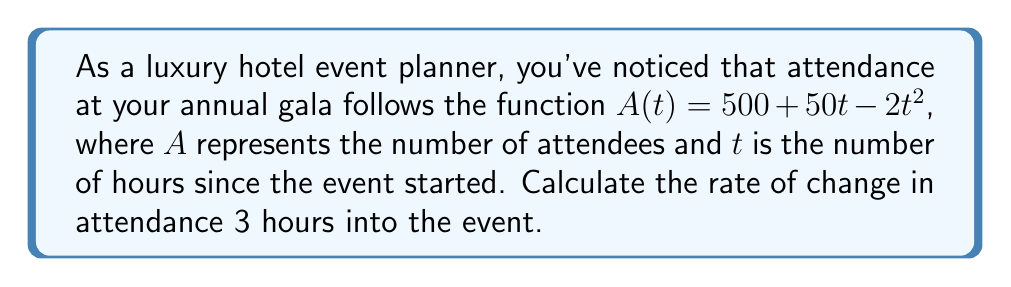Teach me how to tackle this problem. To find the rate of change in attendance at a specific time, we need to calculate the derivative of the attendance function and evaluate it at the given time.

1. The attendance function is: $A(t) = 500 + 50t - 2t^2$

2. To find the rate of change, we need to calculate $\frac{dA}{dt}$:
   $$\frac{dA}{dt} = \frac{d}{dt}(500 + 50t - 2t^2)$$

3. Using the power rule and constant rule of derivatives:
   $$\frac{dA}{dt} = 0 + 50 - 4t$$

4. Simplify:
   $$\frac{dA}{dt} = 50 - 4t$$

5. Now, we need to evaluate this at $t = 3$ hours:
   $$\frac{dA}{dt}\bigg|_{t=3} = 50 - 4(3) = 50 - 12 = 38$$

Therefore, 3 hours into the event, the rate of change in attendance is 38 attendees per hour.
Answer: 38 attendees/hour 